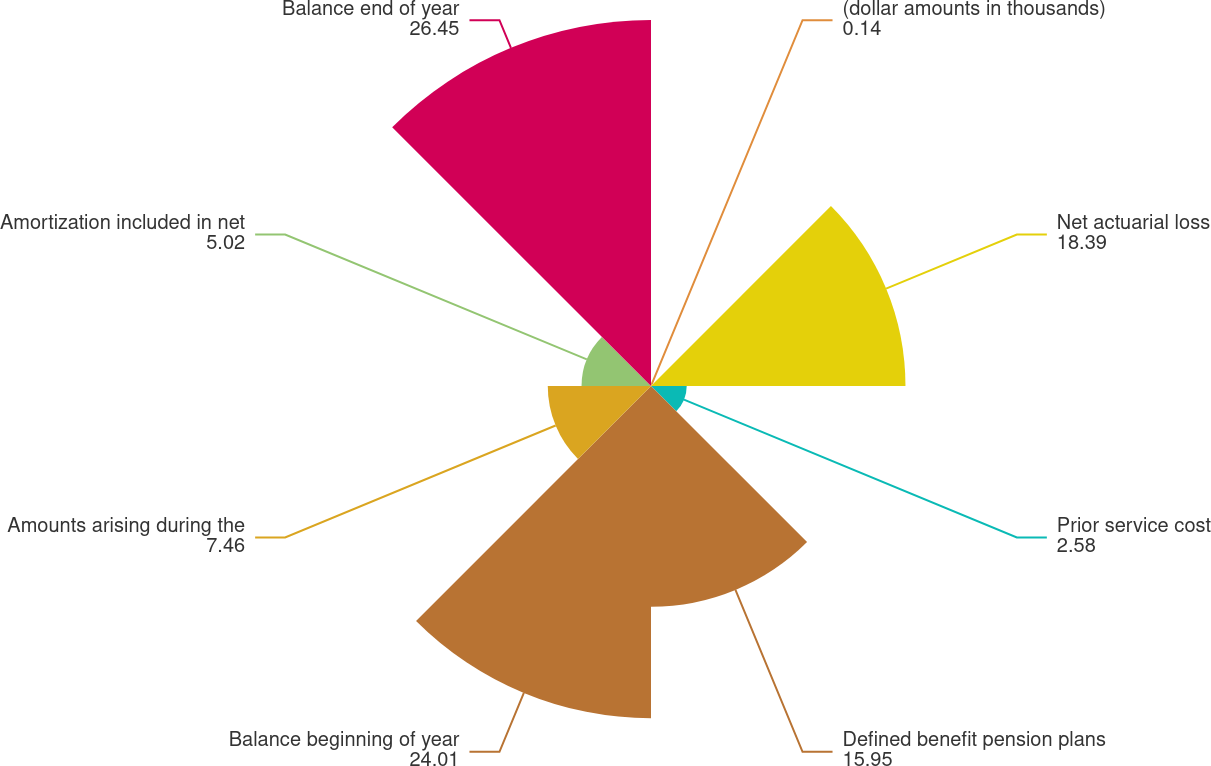Convert chart. <chart><loc_0><loc_0><loc_500><loc_500><pie_chart><fcel>(dollar amounts in thousands)<fcel>Net actuarial loss<fcel>Prior service cost<fcel>Defined benefit pension plans<fcel>Balance beginning of year<fcel>Amounts arising during the<fcel>Amortization included in net<fcel>Balance end of year<nl><fcel>0.14%<fcel>18.39%<fcel>2.58%<fcel>15.95%<fcel>24.01%<fcel>7.46%<fcel>5.02%<fcel>26.45%<nl></chart> 